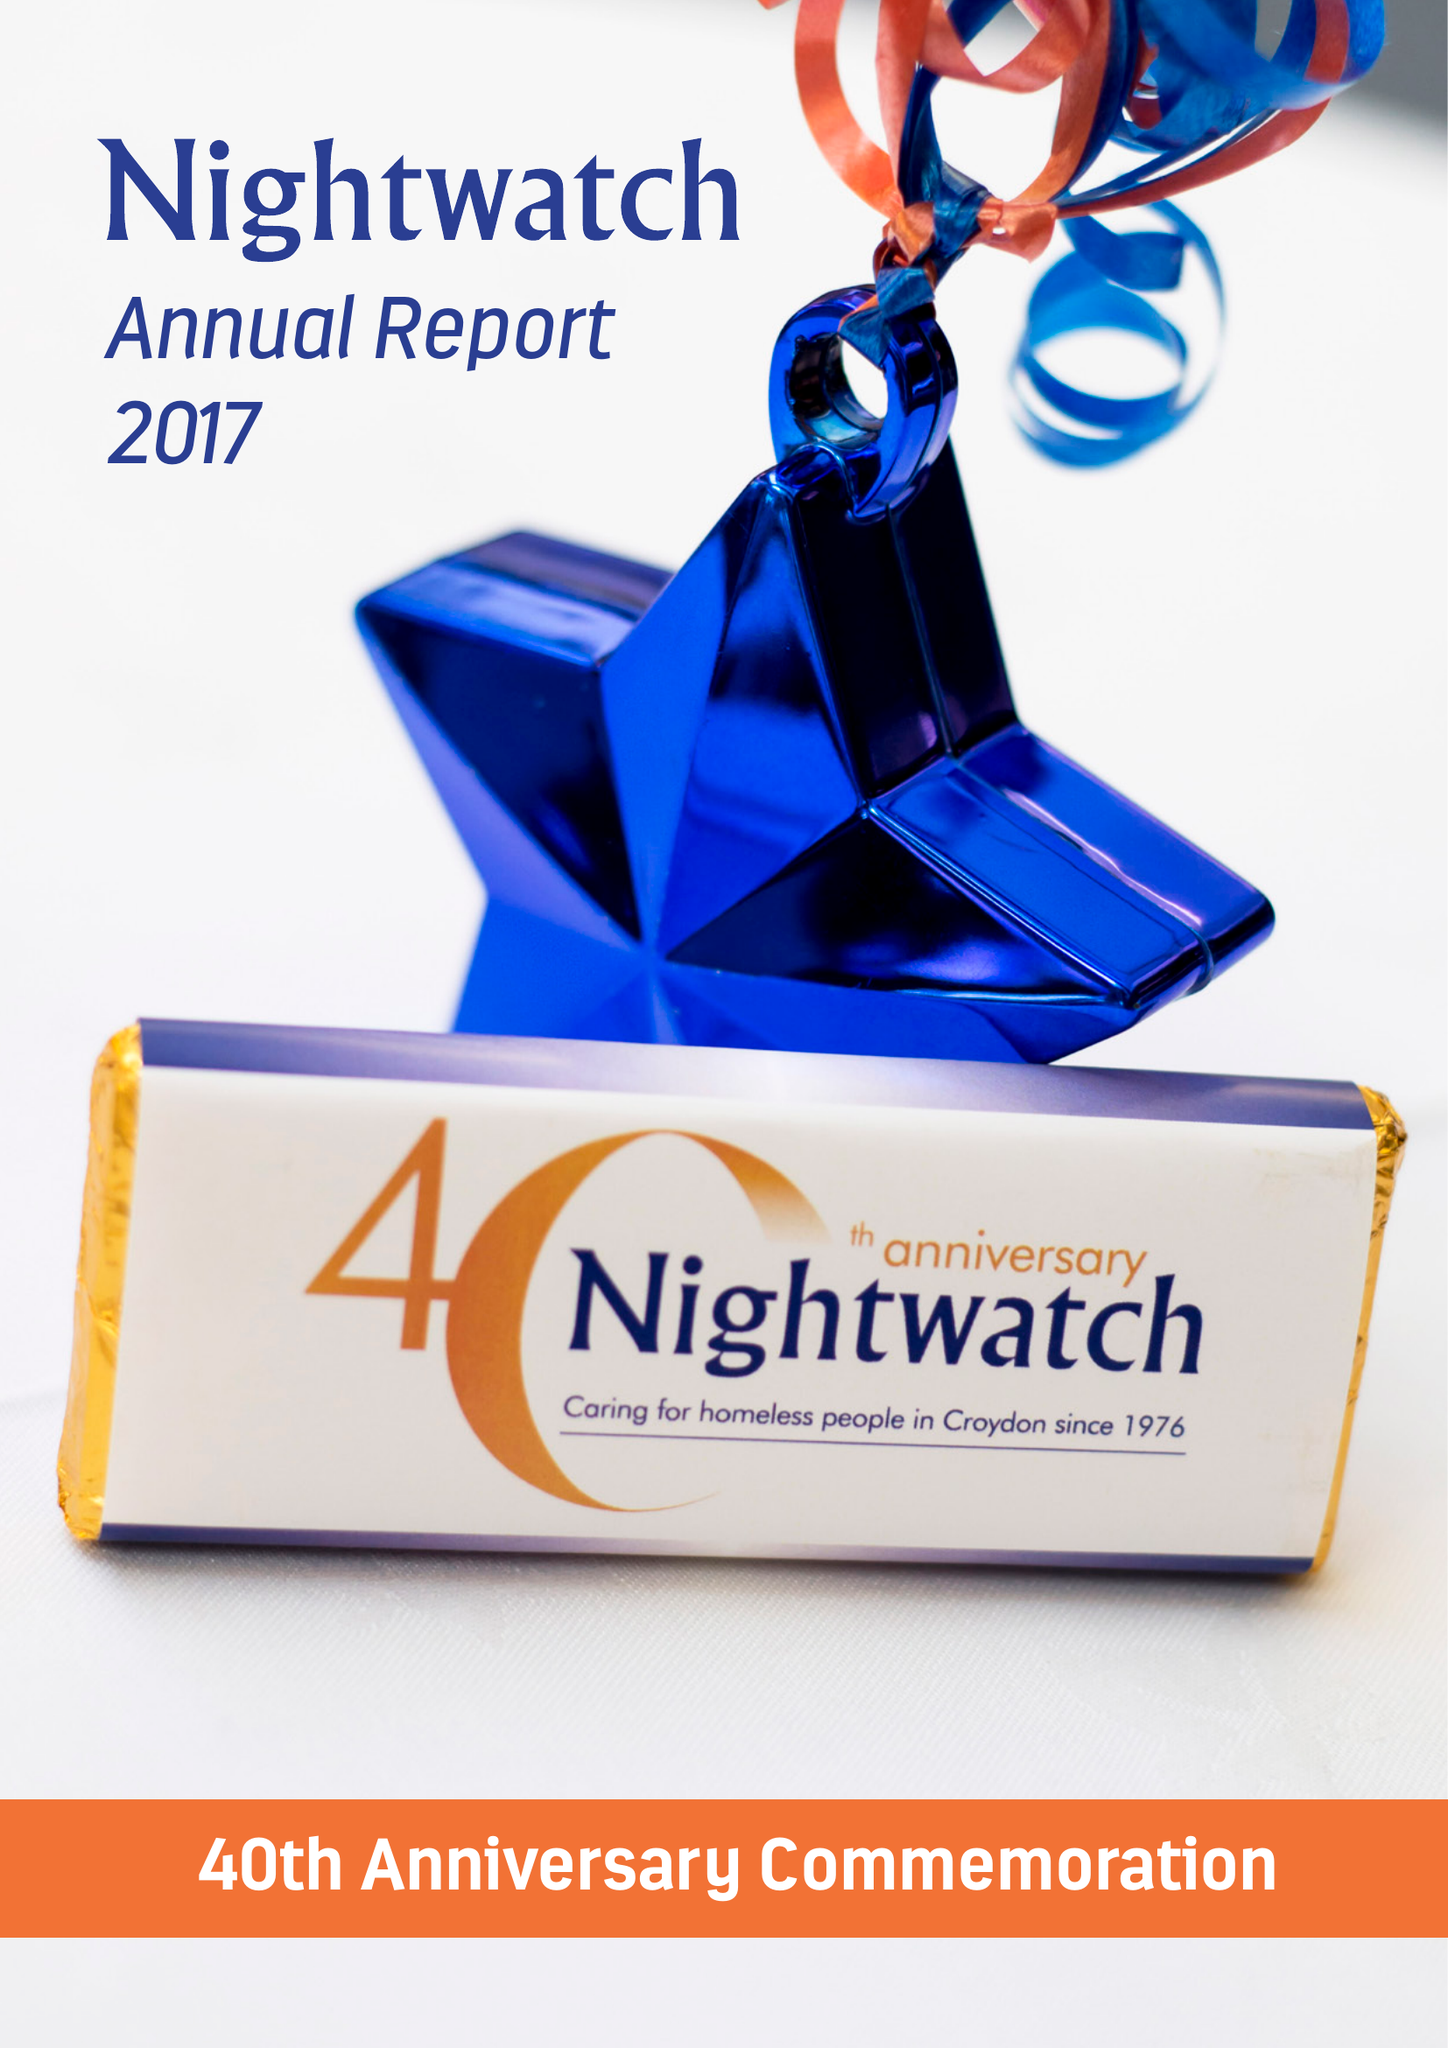What is the value for the spending_annually_in_british_pounds?
Answer the question using a single word or phrase. 61092.00 